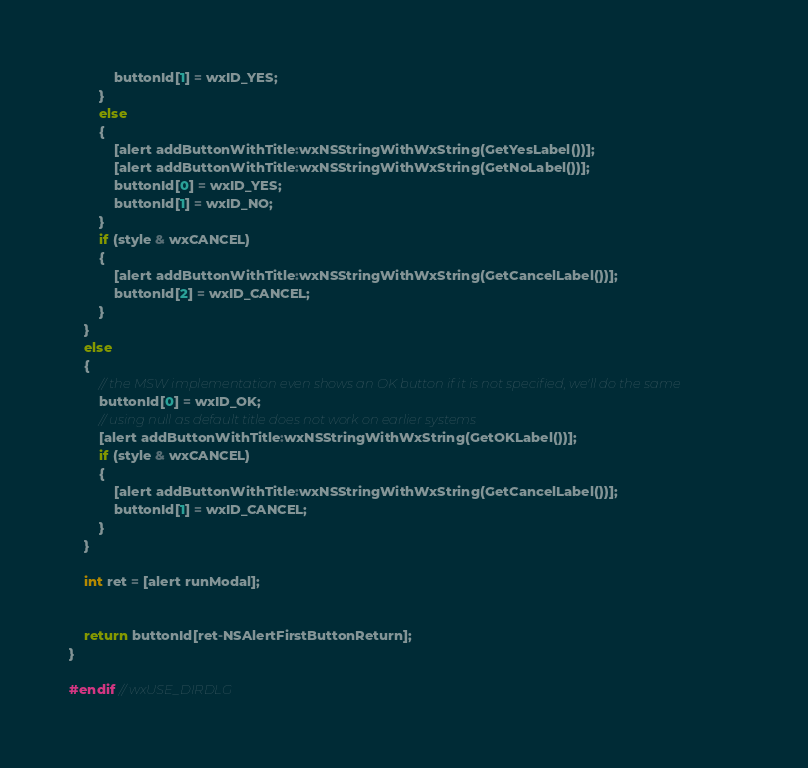<code> <loc_0><loc_0><loc_500><loc_500><_ObjectiveC_>            buttonId[1] = wxID_YES;
        }
        else
        {
            [alert addButtonWithTitle:wxNSStringWithWxString(GetYesLabel())];
            [alert addButtonWithTitle:wxNSStringWithWxString(GetNoLabel())];
            buttonId[0] = wxID_YES;
            buttonId[1] = wxID_NO;
        }
        if (style & wxCANCEL)
        {
            [alert addButtonWithTitle:wxNSStringWithWxString(GetCancelLabel())];
            buttonId[2] = wxID_CANCEL;
        }
    }
    else
    {
        // the MSW implementation even shows an OK button if it is not specified, we'll do the same
        buttonId[0] = wxID_OK;
        // using null as default title does not work on earlier systems
        [alert addButtonWithTitle:wxNSStringWithWxString(GetOKLabel())];
        if (style & wxCANCEL)
        {
            [alert addButtonWithTitle:wxNSStringWithWxString(GetCancelLabel())];
            buttonId[1] = wxID_CANCEL;
        }
    }

    int ret = [alert runModal];


    return buttonId[ret-NSAlertFirstButtonReturn];
}

#endif // wxUSE_DIRDLG

</code> 